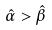Convert formula to latex. <formula><loc_0><loc_0><loc_500><loc_500>\hat { \alpha } > \hat { \beta }</formula> 